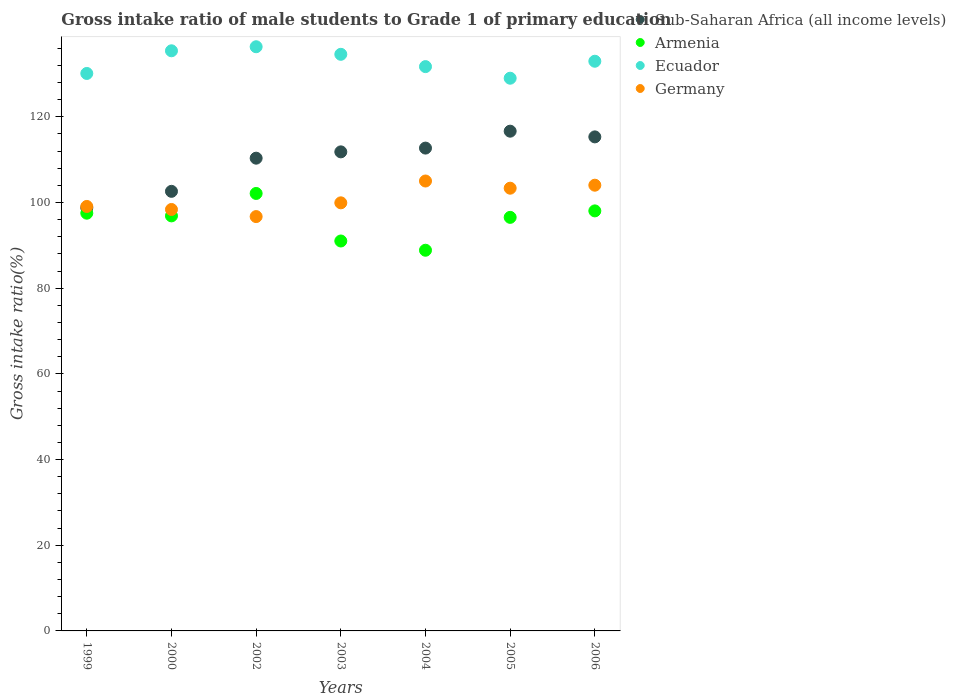What is the gross intake ratio in Armenia in 1999?
Ensure brevity in your answer.  97.51. Across all years, what is the maximum gross intake ratio in Germany?
Ensure brevity in your answer.  105.03. Across all years, what is the minimum gross intake ratio in Sub-Saharan Africa (all income levels)?
Provide a succinct answer. 98.76. In which year was the gross intake ratio in Sub-Saharan Africa (all income levels) maximum?
Ensure brevity in your answer.  2005. What is the total gross intake ratio in Germany in the graph?
Make the answer very short. 706.54. What is the difference between the gross intake ratio in Armenia in 2003 and that in 2005?
Give a very brief answer. -5.52. What is the difference between the gross intake ratio in Ecuador in 2006 and the gross intake ratio in Germany in 2002?
Provide a succinct answer. 36.26. What is the average gross intake ratio in Armenia per year?
Give a very brief answer. 95.86. In the year 2006, what is the difference between the gross intake ratio in Armenia and gross intake ratio in Sub-Saharan Africa (all income levels)?
Your answer should be very brief. -17.28. What is the ratio of the gross intake ratio in Germany in 2004 to that in 2006?
Your response must be concise. 1.01. Is the difference between the gross intake ratio in Armenia in 2000 and 2006 greater than the difference between the gross intake ratio in Sub-Saharan Africa (all income levels) in 2000 and 2006?
Your answer should be very brief. Yes. What is the difference between the highest and the second highest gross intake ratio in Armenia?
Offer a very short reply. 4.07. What is the difference between the highest and the lowest gross intake ratio in Ecuador?
Give a very brief answer. 7.34. Is it the case that in every year, the sum of the gross intake ratio in Sub-Saharan Africa (all income levels) and gross intake ratio in Ecuador  is greater than the sum of gross intake ratio in Germany and gross intake ratio in Armenia?
Give a very brief answer. Yes. Does the gross intake ratio in Germany monotonically increase over the years?
Make the answer very short. No. Is the gross intake ratio in Ecuador strictly less than the gross intake ratio in Sub-Saharan Africa (all income levels) over the years?
Your answer should be very brief. No. What is the difference between two consecutive major ticks on the Y-axis?
Ensure brevity in your answer.  20. Are the values on the major ticks of Y-axis written in scientific E-notation?
Your answer should be compact. No. Does the graph contain any zero values?
Make the answer very short. No. Does the graph contain grids?
Offer a very short reply. No. How are the legend labels stacked?
Give a very brief answer. Vertical. What is the title of the graph?
Ensure brevity in your answer.  Gross intake ratio of male students to Grade 1 of primary education. What is the label or title of the Y-axis?
Your answer should be very brief. Gross intake ratio(%). What is the Gross intake ratio(%) of Sub-Saharan Africa (all income levels) in 1999?
Your answer should be compact. 98.76. What is the Gross intake ratio(%) of Armenia in 1999?
Your answer should be very brief. 97.51. What is the Gross intake ratio(%) in Ecuador in 1999?
Make the answer very short. 130.13. What is the Gross intake ratio(%) of Germany in 1999?
Offer a very short reply. 99.09. What is the Gross intake ratio(%) of Sub-Saharan Africa (all income levels) in 2000?
Your answer should be very brief. 102.61. What is the Gross intake ratio(%) of Armenia in 2000?
Provide a short and direct response. 96.89. What is the Gross intake ratio(%) in Ecuador in 2000?
Keep it short and to the point. 135.42. What is the Gross intake ratio(%) in Germany in 2000?
Provide a short and direct response. 98.38. What is the Gross intake ratio(%) in Sub-Saharan Africa (all income levels) in 2002?
Ensure brevity in your answer.  110.36. What is the Gross intake ratio(%) in Armenia in 2002?
Keep it short and to the point. 102.12. What is the Gross intake ratio(%) in Ecuador in 2002?
Your answer should be compact. 136.37. What is the Gross intake ratio(%) in Germany in 2002?
Provide a short and direct response. 96.72. What is the Gross intake ratio(%) in Sub-Saharan Africa (all income levels) in 2003?
Offer a terse response. 111.83. What is the Gross intake ratio(%) of Armenia in 2003?
Provide a succinct answer. 91.02. What is the Gross intake ratio(%) of Ecuador in 2003?
Offer a very short reply. 134.6. What is the Gross intake ratio(%) of Germany in 2003?
Your response must be concise. 99.93. What is the Gross intake ratio(%) in Sub-Saharan Africa (all income levels) in 2004?
Keep it short and to the point. 112.71. What is the Gross intake ratio(%) of Armenia in 2004?
Offer a terse response. 88.86. What is the Gross intake ratio(%) in Ecuador in 2004?
Offer a terse response. 131.73. What is the Gross intake ratio(%) in Germany in 2004?
Your answer should be very brief. 105.03. What is the Gross intake ratio(%) of Sub-Saharan Africa (all income levels) in 2005?
Give a very brief answer. 116.66. What is the Gross intake ratio(%) of Armenia in 2005?
Give a very brief answer. 96.54. What is the Gross intake ratio(%) in Ecuador in 2005?
Make the answer very short. 129.02. What is the Gross intake ratio(%) of Germany in 2005?
Ensure brevity in your answer.  103.35. What is the Gross intake ratio(%) in Sub-Saharan Africa (all income levels) in 2006?
Give a very brief answer. 115.33. What is the Gross intake ratio(%) in Armenia in 2006?
Provide a succinct answer. 98.05. What is the Gross intake ratio(%) of Ecuador in 2006?
Give a very brief answer. 132.98. What is the Gross intake ratio(%) of Germany in 2006?
Offer a terse response. 104.05. Across all years, what is the maximum Gross intake ratio(%) in Sub-Saharan Africa (all income levels)?
Ensure brevity in your answer.  116.66. Across all years, what is the maximum Gross intake ratio(%) in Armenia?
Make the answer very short. 102.12. Across all years, what is the maximum Gross intake ratio(%) in Ecuador?
Offer a terse response. 136.37. Across all years, what is the maximum Gross intake ratio(%) of Germany?
Make the answer very short. 105.03. Across all years, what is the minimum Gross intake ratio(%) of Sub-Saharan Africa (all income levels)?
Keep it short and to the point. 98.76. Across all years, what is the minimum Gross intake ratio(%) of Armenia?
Offer a very short reply. 88.86. Across all years, what is the minimum Gross intake ratio(%) of Ecuador?
Give a very brief answer. 129.02. Across all years, what is the minimum Gross intake ratio(%) of Germany?
Your response must be concise. 96.72. What is the total Gross intake ratio(%) in Sub-Saharan Africa (all income levels) in the graph?
Your answer should be very brief. 768.26. What is the total Gross intake ratio(%) of Armenia in the graph?
Keep it short and to the point. 671. What is the total Gross intake ratio(%) of Ecuador in the graph?
Keep it short and to the point. 930.26. What is the total Gross intake ratio(%) of Germany in the graph?
Provide a succinct answer. 706.54. What is the difference between the Gross intake ratio(%) in Sub-Saharan Africa (all income levels) in 1999 and that in 2000?
Your answer should be compact. -3.85. What is the difference between the Gross intake ratio(%) in Armenia in 1999 and that in 2000?
Your response must be concise. 0.63. What is the difference between the Gross intake ratio(%) in Ecuador in 1999 and that in 2000?
Ensure brevity in your answer.  -5.29. What is the difference between the Gross intake ratio(%) in Germany in 1999 and that in 2000?
Offer a terse response. 0.71. What is the difference between the Gross intake ratio(%) of Sub-Saharan Africa (all income levels) in 1999 and that in 2002?
Give a very brief answer. -11.59. What is the difference between the Gross intake ratio(%) of Armenia in 1999 and that in 2002?
Give a very brief answer. -4.61. What is the difference between the Gross intake ratio(%) in Ecuador in 1999 and that in 2002?
Your response must be concise. -6.23. What is the difference between the Gross intake ratio(%) of Germany in 1999 and that in 2002?
Keep it short and to the point. 2.37. What is the difference between the Gross intake ratio(%) in Sub-Saharan Africa (all income levels) in 1999 and that in 2003?
Keep it short and to the point. -13.07. What is the difference between the Gross intake ratio(%) in Armenia in 1999 and that in 2003?
Your answer should be compact. 6.49. What is the difference between the Gross intake ratio(%) of Ecuador in 1999 and that in 2003?
Give a very brief answer. -4.47. What is the difference between the Gross intake ratio(%) in Germany in 1999 and that in 2003?
Provide a succinct answer. -0.84. What is the difference between the Gross intake ratio(%) of Sub-Saharan Africa (all income levels) in 1999 and that in 2004?
Keep it short and to the point. -13.95. What is the difference between the Gross intake ratio(%) in Armenia in 1999 and that in 2004?
Offer a very short reply. 8.65. What is the difference between the Gross intake ratio(%) in Ecuador in 1999 and that in 2004?
Provide a succinct answer. -1.6. What is the difference between the Gross intake ratio(%) in Germany in 1999 and that in 2004?
Provide a succinct answer. -5.94. What is the difference between the Gross intake ratio(%) of Sub-Saharan Africa (all income levels) in 1999 and that in 2005?
Your answer should be compact. -17.89. What is the difference between the Gross intake ratio(%) of Armenia in 1999 and that in 2005?
Make the answer very short. 0.97. What is the difference between the Gross intake ratio(%) in Ecuador in 1999 and that in 2005?
Make the answer very short. 1.11. What is the difference between the Gross intake ratio(%) in Germany in 1999 and that in 2005?
Provide a short and direct response. -4.26. What is the difference between the Gross intake ratio(%) in Sub-Saharan Africa (all income levels) in 1999 and that in 2006?
Your answer should be very brief. -16.56. What is the difference between the Gross intake ratio(%) of Armenia in 1999 and that in 2006?
Ensure brevity in your answer.  -0.54. What is the difference between the Gross intake ratio(%) of Ecuador in 1999 and that in 2006?
Make the answer very short. -2.85. What is the difference between the Gross intake ratio(%) in Germany in 1999 and that in 2006?
Make the answer very short. -4.96. What is the difference between the Gross intake ratio(%) in Sub-Saharan Africa (all income levels) in 2000 and that in 2002?
Your answer should be compact. -7.74. What is the difference between the Gross intake ratio(%) in Armenia in 2000 and that in 2002?
Make the answer very short. -5.24. What is the difference between the Gross intake ratio(%) in Ecuador in 2000 and that in 2002?
Your answer should be compact. -0.94. What is the difference between the Gross intake ratio(%) of Germany in 2000 and that in 2002?
Keep it short and to the point. 1.66. What is the difference between the Gross intake ratio(%) of Sub-Saharan Africa (all income levels) in 2000 and that in 2003?
Offer a very short reply. -9.22. What is the difference between the Gross intake ratio(%) of Armenia in 2000 and that in 2003?
Provide a short and direct response. 5.86. What is the difference between the Gross intake ratio(%) in Ecuador in 2000 and that in 2003?
Provide a succinct answer. 0.82. What is the difference between the Gross intake ratio(%) in Germany in 2000 and that in 2003?
Your answer should be very brief. -1.55. What is the difference between the Gross intake ratio(%) of Sub-Saharan Africa (all income levels) in 2000 and that in 2004?
Your answer should be very brief. -10.1. What is the difference between the Gross intake ratio(%) in Armenia in 2000 and that in 2004?
Make the answer very short. 8.02. What is the difference between the Gross intake ratio(%) of Ecuador in 2000 and that in 2004?
Provide a succinct answer. 3.69. What is the difference between the Gross intake ratio(%) in Germany in 2000 and that in 2004?
Make the answer very short. -6.65. What is the difference between the Gross intake ratio(%) of Sub-Saharan Africa (all income levels) in 2000 and that in 2005?
Give a very brief answer. -14.04. What is the difference between the Gross intake ratio(%) of Armenia in 2000 and that in 2005?
Ensure brevity in your answer.  0.35. What is the difference between the Gross intake ratio(%) of Ecuador in 2000 and that in 2005?
Your answer should be very brief. 6.4. What is the difference between the Gross intake ratio(%) in Germany in 2000 and that in 2005?
Give a very brief answer. -4.97. What is the difference between the Gross intake ratio(%) of Sub-Saharan Africa (all income levels) in 2000 and that in 2006?
Make the answer very short. -12.71. What is the difference between the Gross intake ratio(%) in Armenia in 2000 and that in 2006?
Ensure brevity in your answer.  -1.17. What is the difference between the Gross intake ratio(%) of Ecuador in 2000 and that in 2006?
Keep it short and to the point. 2.44. What is the difference between the Gross intake ratio(%) of Germany in 2000 and that in 2006?
Offer a terse response. -5.67. What is the difference between the Gross intake ratio(%) in Sub-Saharan Africa (all income levels) in 2002 and that in 2003?
Your answer should be very brief. -1.47. What is the difference between the Gross intake ratio(%) of Armenia in 2002 and that in 2003?
Provide a short and direct response. 11.1. What is the difference between the Gross intake ratio(%) in Ecuador in 2002 and that in 2003?
Give a very brief answer. 1.77. What is the difference between the Gross intake ratio(%) of Germany in 2002 and that in 2003?
Ensure brevity in your answer.  -3.21. What is the difference between the Gross intake ratio(%) of Sub-Saharan Africa (all income levels) in 2002 and that in 2004?
Your response must be concise. -2.35. What is the difference between the Gross intake ratio(%) in Armenia in 2002 and that in 2004?
Your response must be concise. 13.26. What is the difference between the Gross intake ratio(%) in Ecuador in 2002 and that in 2004?
Give a very brief answer. 4.64. What is the difference between the Gross intake ratio(%) in Germany in 2002 and that in 2004?
Your answer should be very brief. -8.3. What is the difference between the Gross intake ratio(%) of Armenia in 2002 and that in 2005?
Provide a succinct answer. 5.58. What is the difference between the Gross intake ratio(%) of Ecuador in 2002 and that in 2005?
Provide a short and direct response. 7.34. What is the difference between the Gross intake ratio(%) of Germany in 2002 and that in 2005?
Provide a succinct answer. -6.63. What is the difference between the Gross intake ratio(%) in Sub-Saharan Africa (all income levels) in 2002 and that in 2006?
Provide a succinct answer. -4.97. What is the difference between the Gross intake ratio(%) in Armenia in 2002 and that in 2006?
Keep it short and to the point. 4.07. What is the difference between the Gross intake ratio(%) of Ecuador in 2002 and that in 2006?
Your answer should be very brief. 3.38. What is the difference between the Gross intake ratio(%) of Germany in 2002 and that in 2006?
Keep it short and to the point. -7.32. What is the difference between the Gross intake ratio(%) of Sub-Saharan Africa (all income levels) in 2003 and that in 2004?
Ensure brevity in your answer.  -0.88. What is the difference between the Gross intake ratio(%) in Armenia in 2003 and that in 2004?
Make the answer very short. 2.16. What is the difference between the Gross intake ratio(%) of Ecuador in 2003 and that in 2004?
Your response must be concise. 2.87. What is the difference between the Gross intake ratio(%) in Germany in 2003 and that in 2004?
Offer a terse response. -5.09. What is the difference between the Gross intake ratio(%) in Sub-Saharan Africa (all income levels) in 2003 and that in 2005?
Provide a succinct answer. -4.83. What is the difference between the Gross intake ratio(%) of Armenia in 2003 and that in 2005?
Provide a short and direct response. -5.52. What is the difference between the Gross intake ratio(%) of Ecuador in 2003 and that in 2005?
Your answer should be compact. 5.58. What is the difference between the Gross intake ratio(%) in Germany in 2003 and that in 2005?
Offer a very short reply. -3.42. What is the difference between the Gross intake ratio(%) of Sub-Saharan Africa (all income levels) in 2003 and that in 2006?
Make the answer very short. -3.5. What is the difference between the Gross intake ratio(%) in Armenia in 2003 and that in 2006?
Your answer should be compact. -7.03. What is the difference between the Gross intake ratio(%) in Ecuador in 2003 and that in 2006?
Make the answer very short. 1.62. What is the difference between the Gross intake ratio(%) of Germany in 2003 and that in 2006?
Keep it short and to the point. -4.12. What is the difference between the Gross intake ratio(%) in Sub-Saharan Africa (all income levels) in 2004 and that in 2005?
Your answer should be very brief. -3.95. What is the difference between the Gross intake ratio(%) of Armenia in 2004 and that in 2005?
Give a very brief answer. -7.67. What is the difference between the Gross intake ratio(%) of Ecuador in 2004 and that in 2005?
Make the answer very short. 2.71. What is the difference between the Gross intake ratio(%) in Germany in 2004 and that in 2005?
Provide a short and direct response. 1.68. What is the difference between the Gross intake ratio(%) in Sub-Saharan Africa (all income levels) in 2004 and that in 2006?
Keep it short and to the point. -2.62. What is the difference between the Gross intake ratio(%) in Armenia in 2004 and that in 2006?
Ensure brevity in your answer.  -9.19. What is the difference between the Gross intake ratio(%) of Ecuador in 2004 and that in 2006?
Your answer should be very brief. -1.26. What is the difference between the Gross intake ratio(%) of Germany in 2004 and that in 2006?
Make the answer very short. 0.98. What is the difference between the Gross intake ratio(%) of Sub-Saharan Africa (all income levels) in 2005 and that in 2006?
Your answer should be very brief. 1.33. What is the difference between the Gross intake ratio(%) in Armenia in 2005 and that in 2006?
Give a very brief answer. -1.51. What is the difference between the Gross intake ratio(%) of Ecuador in 2005 and that in 2006?
Your answer should be compact. -3.96. What is the difference between the Gross intake ratio(%) in Germany in 2005 and that in 2006?
Ensure brevity in your answer.  -0.7. What is the difference between the Gross intake ratio(%) of Sub-Saharan Africa (all income levels) in 1999 and the Gross intake ratio(%) of Armenia in 2000?
Offer a terse response. 1.88. What is the difference between the Gross intake ratio(%) of Sub-Saharan Africa (all income levels) in 1999 and the Gross intake ratio(%) of Ecuador in 2000?
Your answer should be compact. -36.66. What is the difference between the Gross intake ratio(%) of Sub-Saharan Africa (all income levels) in 1999 and the Gross intake ratio(%) of Germany in 2000?
Make the answer very short. 0.38. What is the difference between the Gross intake ratio(%) of Armenia in 1999 and the Gross intake ratio(%) of Ecuador in 2000?
Ensure brevity in your answer.  -37.91. What is the difference between the Gross intake ratio(%) of Armenia in 1999 and the Gross intake ratio(%) of Germany in 2000?
Your response must be concise. -0.87. What is the difference between the Gross intake ratio(%) of Ecuador in 1999 and the Gross intake ratio(%) of Germany in 2000?
Ensure brevity in your answer.  31.75. What is the difference between the Gross intake ratio(%) in Sub-Saharan Africa (all income levels) in 1999 and the Gross intake ratio(%) in Armenia in 2002?
Your answer should be very brief. -3.36. What is the difference between the Gross intake ratio(%) of Sub-Saharan Africa (all income levels) in 1999 and the Gross intake ratio(%) of Ecuador in 2002?
Provide a short and direct response. -37.6. What is the difference between the Gross intake ratio(%) in Sub-Saharan Africa (all income levels) in 1999 and the Gross intake ratio(%) in Germany in 2002?
Keep it short and to the point. 2.04. What is the difference between the Gross intake ratio(%) of Armenia in 1999 and the Gross intake ratio(%) of Ecuador in 2002?
Offer a very short reply. -38.85. What is the difference between the Gross intake ratio(%) in Armenia in 1999 and the Gross intake ratio(%) in Germany in 2002?
Provide a short and direct response. 0.79. What is the difference between the Gross intake ratio(%) of Ecuador in 1999 and the Gross intake ratio(%) of Germany in 2002?
Give a very brief answer. 33.41. What is the difference between the Gross intake ratio(%) in Sub-Saharan Africa (all income levels) in 1999 and the Gross intake ratio(%) in Armenia in 2003?
Your response must be concise. 7.74. What is the difference between the Gross intake ratio(%) in Sub-Saharan Africa (all income levels) in 1999 and the Gross intake ratio(%) in Ecuador in 2003?
Ensure brevity in your answer.  -35.84. What is the difference between the Gross intake ratio(%) of Sub-Saharan Africa (all income levels) in 1999 and the Gross intake ratio(%) of Germany in 2003?
Ensure brevity in your answer.  -1.17. What is the difference between the Gross intake ratio(%) of Armenia in 1999 and the Gross intake ratio(%) of Ecuador in 2003?
Provide a succinct answer. -37.09. What is the difference between the Gross intake ratio(%) in Armenia in 1999 and the Gross intake ratio(%) in Germany in 2003?
Give a very brief answer. -2.42. What is the difference between the Gross intake ratio(%) in Ecuador in 1999 and the Gross intake ratio(%) in Germany in 2003?
Your response must be concise. 30.2. What is the difference between the Gross intake ratio(%) of Sub-Saharan Africa (all income levels) in 1999 and the Gross intake ratio(%) of Armenia in 2004?
Offer a terse response. 9.9. What is the difference between the Gross intake ratio(%) in Sub-Saharan Africa (all income levels) in 1999 and the Gross intake ratio(%) in Ecuador in 2004?
Ensure brevity in your answer.  -32.97. What is the difference between the Gross intake ratio(%) of Sub-Saharan Africa (all income levels) in 1999 and the Gross intake ratio(%) of Germany in 2004?
Offer a very short reply. -6.26. What is the difference between the Gross intake ratio(%) in Armenia in 1999 and the Gross intake ratio(%) in Ecuador in 2004?
Offer a terse response. -34.22. What is the difference between the Gross intake ratio(%) of Armenia in 1999 and the Gross intake ratio(%) of Germany in 2004?
Make the answer very short. -7.51. What is the difference between the Gross intake ratio(%) in Ecuador in 1999 and the Gross intake ratio(%) in Germany in 2004?
Your answer should be compact. 25.11. What is the difference between the Gross intake ratio(%) of Sub-Saharan Africa (all income levels) in 1999 and the Gross intake ratio(%) of Armenia in 2005?
Keep it short and to the point. 2.22. What is the difference between the Gross intake ratio(%) of Sub-Saharan Africa (all income levels) in 1999 and the Gross intake ratio(%) of Ecuador in 2005?
Give a very brief answer. -30.26. What is the difference between the Gross intake ratio(%) in Sub-Saharan Africa (all income levels) in 1999 and the Gross intake ratio(%) in Germany in 2005?
Give a very brief answer. -4.58. What is the difference between the Gross intake ratio(%) of Armenia in 1999 and the Gross intake ratio(%) of Ecuador in 2005?
Keep it short and to the point. -31.51. What is the difference between the Gross intake ratio(%) of Armenia in 1999 and the Gross intake ratio(%) of Germany in 2005?
Ensure brevity in your answer.  -5.83. What is the difference between the Gross intake ratio(%) in Ecuador in 1999 and the Gross intake ratio(%) in Germany in 2005?
Offer a very short reply. 26.78. What is the difference between the Gross intake ratio(%) of Sub-Saharan Africa (all income levels) in 1999 and the Gross intake ratio(%) of Armenia in 2006?
Ensure brevity in your answer.  0.71. What is the difference between the Gross intake ratio(%) in Sub-Saharan Africa (all income levels) in 1999 and the Gross intake ratio(%) in Ecuador in 2006?
Give a very brief answer. -34.22. What is the difference between the Gross intake ratio(%) in Sub-Saharan Africa (all income levels) in 1999 and the Gross intake ratio(%) in Germany in 2006?
Offer a terse response. -5.28. What is the difference between the Gross intake ratio(%) of Armenia in 1999 and the Gross intake ratio(%) of Ecuador in 2006?
Provide a succinct answer. -35.47. What is the difference between the Gross intake ratio(%) in Armenia in 1999 and the Gross intake ratio(%) in Germany in 2006?
Offer a terse response. -6.53. What is the difference between the Gross intake ratio(%) in Ecuador in 1999 and the Gross intake ratio(%) in Germany in 2006?
Your response must be concise. 26.09. What is the difference between the Gross intake ratio(%) of Sub-Saharan Africa (all income levels) in 2000 and the Gross intake ratio(%) of Armenia in 2002?
Provide a short and direct response. 0.49. What is the difference between the Gross intake ratio(%) of Sub-Saharan Africa (all income levels) in 2000 and the Gross intake ratio(%) of Ecuador in 2002?
Offer a very short reply. -33.75. What is the difference between the Gross intake ratio(%) of Sub-Saharan Africa (all income levels) in 2000 and the Gross intake ratio(%) of Germany in 2002?
Ensure brevity in your answer.  5.89. What is the difference between the Gross intake ratio(%) of Armenia in 2000 and the Gross intake ratio(%) of Ecuador in 2002?
Provide a short and direct response. -39.48. What is the difference between the Gross intake ratio(%) in Armenia in 2000 and the Gross intake ratio(%) in Germany in 2002?
Your answer should be very brief. 0.16. What is the difference between the Gross intake ratio(%) in Ecuador in 2000 and the Gross intake ratio(%) in Germany in 2002?
Provide a short and direct response. 38.7. What is the difference between the Gross intake ratio(%) in Sub-Saharan Africa (all income levels) in 2000 and the Gross intake ratio(%) in Armenia in 2003?
Your answer should be compact. 11.59. What is the difference between the Gross intake ratio(%) in Sub-Saharan Africa (all income levels) in 2000 and the Gross intake ratio(%) in Ecuador in 2003?
Make the answer very short. -31.99. What is the difference between the Gross intake ratio(%) in Sub-Saharan Africa (all income levels) in 2000 and the Gross intake ratio(%) in Germany in 2003?
Provide a succinct answer. 2.68. What is the difference between the Gross intake ratio(%) in Armenia in 2000 and the Gross intake ratio(%) in Ecuador in 2003?
Your response must be concise. -37.72. What is the difference between the Gross intake ratio(%) of Armenia in 2000 and the Gross intake ratio(%) of Germany in 2003?
Provide a short and direct response. -3.05. What is the difference between the Gross intake ratio(%) in Ecuador in 2000 and the Gross intake ratio(%) in Germany in 2003?
Your answer should be compact. 35.49. What is the difference between the Gross intake ratio(%) of Sub-Saharan Africa (all income levels) in 2000 and the Gross intake ratio(%) of Armenia in 2004?
Provide a succinct answer. 13.75. What is the difference between the Gross intake ratio(%) of Sub-Saharan Africa (all income levels) in 2000 and the Gross intake ratio(%) of Ecuador in 2004?
Your response must be concise. -29.12. What is the difference between the Gross intake ratio(%) of Sub-Saharan Africa (all income levels) in 2000 and the Gross intake ratio(%) of Germany in 2004?
Provide a succinct answer. -2.41. What is the difference between the Gross intake ratio(%) of Armenia in 2000 and the Gross intake ratio(%) of Ecuador in 2004?
Offer a very short reply. -34.84. What is the difference between the Gross intake ratio(%) of Armenia in 2000 and the Gross intake ratio(%) of Germany in 2004?
Ensure brevity in your answer.  -8.14. What is the difference between the Gross intake ratio(%) in Ecuador in 2000 and the Gross intake ratio(%) in Germany in 2004?
Offer a terse response. 30.4. What is the difference between the Gross intake ratio(%) of Sub-Saharan Africa (all income levels) in 2000 and the Gross intake ratio(%) of Armenia in 2005?
Provide a short and direct response. 6.07. What is the difference between the Gross intake ratio(%) in Sub-Saharan Africa (all income levels) in 2000 and the Gross intake ratio(%) in Ecuador in 2005?
Make the answer very short. -26.41. What is the difference between the Gross intake ratio(%) of Sub-Saharan Africa (all income levels) in 2000 and the Gross intake ratio(%) of Germany in 2005?
Keep it short and to the point. -0.73. What is the difference between the Gross intake ratio(%) in Armenia in 2000 and the Gross intake ratio(%) in Ecuador in 2005?
Give a very brief answer. -32.14. What is the difference between the Gross intake ratio(%) of Armenia in 2000 and the Gross intake ratio(%) of Germany in 2005?
Your answer should be compact. -6.46. What is the difference between the Gross intake ratio(%) in Ecuador in 2000 and the Gross intake ratio(%) in Germany in 2005?
Your response must be concise. 32.07. What is the difference between the Gross intake ratio(%) in Sub-Saharan Africa (all income levels) in 2000 and the Gross intake ratio(%) in Armenia in 2006?
Keep it short and to the point. 4.56. What is the difference between the Gross intake ratio(%) of Sub-Saharan Africa (all income levels) in 2000 and the Gross intake ratio(%) of Ecuador in 2006?
Ensure brevity in your answer.  -30.37. What is the difference between the Gross intake ratio(%) in Sub-Saharan Africa (all income levels) in 2000 and the Gross intake ratio(%) in Germany in 2006?
Offer a terse response. -1.43. What is the difference between the Gross intake ratio(%) of Armenia in 2000 and the Gross intake ratio(%) of Ecuador in 2006?
Your response must be concise. -36.1. What is the difference between the Gross intake ratio(%) in Armenia in 2000 and the Gross intake ratio(%) in Germany in 2006?
Your response must be concise. -7.16. What is the difference between the Gross intake ratio(%) in Ecuador in 2000 and the Gross intake ratio(%) in Germany in 2006?
Provide a succinct answer. 31.38. What is the difference between the Gross intake ratio(%) of Sub-Saharan Africa (all income levels) in 2002 and the Gross intake ratio(%) of Armenia in 2003?
Keep it short and to the point. 19.33. What is the difference between the Gross intake ratio(%) of Sub-Saharan Africa (all income levels) in 2002 and the Gross intake ratio(%) of Ecuador in 2003?
Give a very brief answer. -24.24. What is the difference between the Gross intake ratio(%) in Sub-Saharan Africa (all income levels) in 2002 and the Gross intake ratio(%) in Germany in 2003?
Provide a succinct answer. 10.42. What is the difference between the Gross intake ratio(%) in Armenia in 2002 and the Gross intake ratio(%) in Ecuador in 2003?
Offer a very short reply. -32.48. What is the difference between the Gross intake ratio(%) of Armenia in 2002 and the Gross intake ratio(%) of Germany in 2003?
Make the answer very short. 2.19. What is the difference between the Gross intake ratio(%) of Ecuador in 2002 and the Gross intake ratio(%) of Germany in 2003?
Your answer should be very brief. 36.44. What is the difference between the Gross intake ratio(%) in Sub-Saharan Africa (all income levels) in 2002 and the Gross intake ratio(%) in Armenia in 2004?
Offer a very short reply. 21.49. What is the difference between the Gross intake ratio(%) of Sub-Saharan Africa (all income levels) in 2002 and the Gross intake ratio(%) of Ecuador in 2004?
Make the answer very short. -21.37. What is the difference between the Gross intake ratio(%) in Sub-Saharan Africa (all income levels) in 2002 and the Gross intake ratio(%) in Germany in 2004?
Your response must be concise. 5.33. What is the difference between the Gross intake ratio(%) of Armenia in 2002 and the Gross intake ratio(%) of Ecuador in 2004?
Provide a succinct answer. -29.61. What is the difference between the Gross intake ratio(%) in Armenia in 2002 and the Gross intake ratio(%) in Germany in 2004?
Provide a short and direct response. -2.9. What is the difference between the Gross intake ratio(%) of Ecuador in 2002 and the Gross intake ratio(%) of Germany in 2004?
Your response must be concise. 31.34. What is the difference between the Gross intake ratio(%) of Sub-Saharan Africa (all income levels) in 2002 and the Gross intake ratio(%) of Armenia in 2005?
Give a very brief answer. 13.82. What is the difference between the Gross intake ratio(%) of Sub-Saharan Africa (all income levels) in 2002 and the Gross intake ratio(%) of Ecuador in 2005?
Your answer should be compact. -18.67. What is the difference between the Gross intake ratio(%) of Sub-Saharan Africa (all income levels) in 2002 and the Gross intake ratio(%) of Germany in 2005?
Offer a very short reply. 7.01. What is the difference between the Gross intake ratio(%) in Armenia in 2002 and the Gross intake ratio(%) in Ecuador in 2005?
Offer a very short reply. -26.9. What is the difference between the Gross intake ratio(%) of Armenia in 2002 and the Gross intake ratio(%) of Germany in 2005?
Provide a short and direct response. -1.23. What is the difference between the Gross intake ratio(%) of Ecuador in 2002 and the Gross intake ratio(%) of Germany in 2005?
Your answer should be compact. 33.02. What is the difference between the Gross intake ratio(%) in Sub-Saharan Africa (all income levels) in 2002 and the Gross intake ratio(%) in Armenia in 2006?
Offer a terse response. 12.31. What is the difference between the Gross intake ratio(%) of Sub-Saharan Africa (all income levels) in 2002 and the Gross intake ratio(%) of Ecuador in 2006?
Offer a very short reply. -22.63. What is the difference between the Gross intake ratio(%) of Sub-Saharan Africa (all income levels) in 2002 and the Gross intake ratio(%) of Germany in 2006?
Your answer should be compact. 6.31. What is the difference between the Gross intake ratio(%) of Armenia in 2002 and the Gross intake ratio(%) of Ecuador in 2006?
Keep it short and to the point. -30.86. What is the difference between the Gross intake ratio(%) of Armenia in 2002 and the Gross intake ratio(%) of Germany in 2006?
Offer a very short reply. -1.93. What is the difference between the Gross intake ratio(%) in Ecuador in 2002 and the Gross intake ratio(%) in Germany in 2006?
Your answer should be very brief. 32.32. What is the difference between the Gross intake ratio(%) of Sub-Saharan Africa (all income levels) in 2003 and the Gross intake ratio(%) of Armenia in 2004?
Make the answer very short. 22.96. What is the difference between the Gross intake ratio(%) of Sub-Saharan Africa (all income levels) in 2003 and the Gross intake ratio(%) of Ecuador in 2004?
Offer a very short reply. -19.9. What is the difference between the Gross intake ratio(%) in Sub-Saharan Africa (all income levels) in 2003 and the Gross intake ratio(%) in Germany in 2004?
Give a very brief answer. 6.8. What is the difference between the Gross intake ratio(%) in Armenia in 2003 and the Gross intake ratio(%) in Ecuador in 2004?
Provide a succinct answer. -40.71. What is the difference between the Gross intake ratio(%) of Armenia in 2003 and the Gross intake ratio(%) of Germany in 2004?
Your answer should be compact. -14. What is the difference between the Gross intake ratio(%) of Ecuador in 2003 and the Gross intake ratio(%) of Germany in 2004?
Keep it short and to the point. 29.58. What is the difference between the Gross intake ratio(%) of Sub-Saharan Africa (all income levels) in 2003 and the Gross intake ratio(%) of Armenia in 2005?
Ensure brevity in your answer.  15.29. What is the difference between the Gross intake ratio(%) in Sub-Saharan Africa (all income levels) in 2003 and the Gross intake ratio(%) in Ecuador in 2005?
Keep it short and to the point. -17.19. What is the difference between the Gross intake ratio(%) in Sub-Saharan Africa (all income levels) in 2003 and the Gross intake ratio(%) in Germany in 2005?
Give a very brief answer. 8.48. What is the difference between the Gross intake ratio(%) in Armenia in 2003 and the Gross intake ratio(%) in Ecuador in 2005?
Keep it short and to the point. -38. What is the difference between the Gross intake ratio(%) in Armenia in 2003 and the Gross intake ratio(%) in Germany in 2005?
Offer a very short reply. -12.33. What is the difference between the Gross intake ratio(%) in Ecuador in 2003 and the Gross intake ratio(%) in Germany in 2005?
Give a very brief answer. 31.25. What is the difference between the Gross intake ratio(%) of Sub-Saharan Africa (all income levels) in 2003 and the Gross intake ratio(%) of Armenia in 2006?
Your answer should be very brief. 13.78. What is the difference between the Gross intake ratio(%) of Sub-Saharan Africa (all income levels) in 2003 and the Gross intake ratio(%) of Ecuador in 2006?
Your answer should be compact. -21.15. What is the difference between the Gross intake ratio(%) in Sub-Saharan Africa (all income levels) in 2003 and the Gross intake ratio(%) in Germany in 2006?
Your response must be concise. 7.78. What is the difference between the Gross intake ratio(%) of Armenia in 2003 and the Gross intake ratio(%) of Ecuador in 2006?
Offer a terse response. -41.96. What is the difference between the Gross intake ratio(%) in Armenia in 2003 and the Gross intake ratio(%) in Germany in 2006?
Your response must be concise. -13.03. What is the difference between the Gross intake ratio(%) in Ecuador in 2003 and the Gross intake ratio(%) in Germany in 2006?
Make the answer very short. 30.55. What is the difference between the Gross intake ratio(%) in Sub-Saharan Africa (all income levels) in 2004 and the Gross intake ratio(%) in Armenia in 2005?
Offer a terse response. 16.17. What is the difference between the Gross intake ratio(%) in Sub-Saharan Africa (all income levels) in 2004 and the Gross intake ratio(%) in Ecuador in 2005?
Keep it short and to the point. -16.31. What is the difference between the Gross intake ratio(%) in Sub-Saharan Africa (all income levels) in 2004 and the Gross intake ratio(%) in Germany in 2005?
Keep it short and to the point. 9.36. What is the difference between the Gross intake ratio(%) of Armenia in 2004 and the Gross intake ratio(%) of Ecuador in 2005?
Your answer should be very brief. -40.16. What is the difference between the Gross intake ratio(%) in Armenia in 2004 and the Gross intake ratio(%) in Germany in 2005?
Make the answer very short. -14.48. What is the difference between the Gross intake ratio(%) of Ecuador in 2004 and the Gross intake ratio(%) of Germany in 2005?
Your response must be concise. 28.38. What is the difference between the Gross intake ratio(%) in Sub-Saharan Africa (all income levels) in 2004 and the Gross intake ratio(%) in Armenia in 2006?
Give a very brief answer. 14.66. What is the difference between the Gross intake ratio(%) in Sub-Saharan Africa (all income levels) in 2004 and the Gross intake ratio(%) in Ecuador in 2006?
Your response must be concise. -20.28. What is the difference between the Gross intake ratio(%) in Sub-Saharan Africa (all income levels) in 2004 and the Gross intake ratio(%) in Germany in 2006?
Offer a terse response. 8.66. What is the difference between the Gross intake ratio(%) of Armenia in 2004 and the Gross intake ratio(%) of Ecuador in 2006?
Your answer should be compact. -44.12. What is the difference between the Gross intake ratio(%) of Armenia in 2004 and the Gross intake ratio(%) of Germany in 2006?
Provide a short and direct response. -15.18. What is the difference between the Gross intake ratio(%) in Ecuador in 2004 and the Gross intake ratio(%) in Germany in 2006?
Offer a terse response. 27.68. What is the difference between the Gross intake ratio(%) of Sub-Saharan Africa (all income levels) in 2005 and the Gross intake ratio(%) of Armenia in 2006?
Your response must be concise. 18.61. What is the difference between the Gross intake ratio(%) of Sub-Saharan Africa (all income levels) in 2005 and the Gross intake ratio(%) of Ecuador in 2006?
Your answer should be compact. -16.33. What is the difference between the Gross intake ratio(%) in Sub-Saharan Africa (all income levels) in 2005 and the Gross intake ratio(%) in Germany in 2006?
Give a very brief answer. 12.61. What is the difference between the Gross intake ratio(%) of Armenia in 2005 and the Gross intake ratio(%) of Ecuador in 2006?
Your response must be concise. -36.44. What is the difference between the Gross intake ratio(%) of Armenia in 2005 and the Gross intake ratio(%) of Germany in 2006?
Your answer should be compact. -7.51. What is the difference between the Gross intake ratio(%) of Ecuador in 2005 and the Gross intake ratio(%) of Germany in 2006?
Offer a very short reply. 24.97. What is the average Gross intake ratio(%) in Sub-Saharan Africa (all income levels) per year?
Your answer should be compact. 109.75. What is the average Gross intake ratio(%) in Armenia per year?
Offer a very short reply. 95.86. What is the average Gross intake ratio(%) in Ecuador per year?
Provide a short and direct response. 132.89. What is the average Gross intake ratio(%) of Germany per year?
Your response must be concise. 100.93. In the year 1999, what is the difference between the Gross intake ratio(%) in Sub-Saharan Africa (all income levels) and Gross intake ratio(%) in Armenia?
Give a very brief answer. 1.25. In the year 1999, what is the difference between the Gross intake ratio(%) of Sub-Saharan Africa (all income levels) and Gross intake ratio(%) of Ecuador?
Your answer should be very brief. -31.37. In the year 1999, what is the difference between the Gross intake ratio(%) of Sub-Saharan Africa (all income levels) and Gross intake ratio(%) of Germany?
Provide a succinct answer. -0.32. In the year 1999, what is the difference between the Gross intake ratio(%) in Armenia and Gross intake ratio(%) in Ecuador?
Offer a very short reply. -32.62. In the year 1999, what is the difference between the Gross intake ratio(%) in Armenia and Gross intake ratio(%) in Germany?
Provide a succinct answer. -1.57. In the year 1999, what is the difference between the Gross intake ratio(%) of Ecuador and Gross intake ratio(%) of Germany?
Give a very brief answer. 31.04. In the year 2000, what is the difference between the Gross intake ratio(%) of Sub-Saharan Africa (all income levels) and Gross intake ratio(%) of Armenia?
Provide a succinct answer. 5.73. In the year 2000, what is the difference between the Gross intake ratio(%) in Sub-Saharan Africa (all income levels) and Gross intake ratio(%) in Ecuador?
Provide a short and direct response. -32.81. In the year 2000, what is the difference between the Gross intake ratio(%) in Sub-Saharan Africa (all income levels) and Gross intake ratio(%) in Germany?
Provide a succinct answer. 4.23. In the year 2000, what is the difference between the Gross intake ratio(%) of Armenia and Gross intake ratio(%) of Ecuador?
Ensure brevity in your answer.  -38.54. In the year 2000, what is the difference between the Gross intake ratio(%) in Armenia and Gross intake ratio(%) in Germany?
Offer a very short reply. -1.49. In the year 2000, what is the difference between the Gross intake ratio(%) in Ecuador and Gross intake ratio(%) in Germany?
Ensure brevity in your answer.  37.04. In the year 2002, what is the difference between the Gross intake ratio(%) in Sub-Saharan Africa (all income levels) and Gross intake ratio(%) in Armenia?
Ensure brevity in your answer.  8.24. In the year 2002, what is the difference between the Gross intake ratio(%) in Sub-Saharan Africa (all income levels) and Gross intake ratio(%) in Ecuador?
Your answer should be very brief. -26.01. In the year 2002, what is the difference between the Gross intake ratio(%) of Sub-Saharan Africa (all income levels) and Gross intake ratio(%) of Germany?
Make the answer very short. 13.63. In the year 2002, what is the difference between the Gross intake ratio(%) in Armenia and Gross intake ratio(%) in Ecuador?
Your answer should be compact. -34.25. In the year 2002, what is the difference between the Gross intake ratio(%) in Armenia and Gross intake ratio(%) in Germany?
Make the answer very short. 5.4. In the year 2002, what is the difference between the Gross intake ratio(%) of Ecuador and Gross intake ratio(%) of Germany?
Offer a terse response. 39.64. In the year 2003, what is the difference between the Gross intake ratio(%) in Sub-Saharan Africa (all income levels) and Gross intake ratio(%) in Armenia?
Offer a very short reply. 20.81. In the year 2003, what is the difference between the Gross intake ratio(%) in Sub-Saharan Africa (all income levels) and Gross intake ratio(%) in Ecuador?
Your answer should be compact. -22.77. In the year 2003, what is the difference between the Gross intake ratio(%) of Sub-Saharan Africa (all income levels) and Gross intake ratio(%) of Germany?
Your answer should be very brief. 11.9. In the year 2003, what is the difference between the Gross intake ratio(%) of Armenia and Gross intake ratio(%) of Ecuador?
Give a very brief answer. -43.58. In the year 2003, what is the difference between the Gross intake ratio(%) of Armenia and Gross intake ratio(%) of Germany?
Provide a succinct answer. -8.91. In the year 2003, what is the difference between the Gross intake ratio(%) in Ecuador and Gross intake ratio(%) in Germany?
Your answer should be very brief. 34.67. In the year 2004, what is the difference between the Gross intake ratio(%) of Sub-Saharan Africa (all income levels) and Gross intake ratio(%) of Armenia?
Offer a very short reply. 23.84. In the year 2004, what is the difference between the Gross intake ratio(%) of Sub-Saharan Africa (all income levels) and Gross intake ratio(%) of Ecuador?
Offer a very short reply. -19.02. In the year 2004, what is the difference between the Gross intake ratio(%) in Sub-Saharan Africa (all income levels) and Gross intake ratio(%) in Germany?
Offer a very short reply. 7.68. In the year 2004, what is the difference between the Gross intake ratio(%) of Armenia and Gross intake ratio(%) of Ecuador?
Make the answer very short. -42.86. In the year 2004, what is the difference between the Gross intake ratio(%) in Armenia and Gross intake ratio(%) in Germany?
Your answer should be very brief. -16.16. In the year 2004, what is the difference between the Gross intake ratio(%) in Ecuador and Gross intake ratio(%) in Germany?
Give a very brief answer. 26.7. In the year 2005, what is the difference between the Gross intake ratio(%) in Sub-Saharan Africa (all income levels) and Gross intake ratio(%) in Armenia?
Your answer should be compact. 20.12. In the year 2005, what is the difference between the Gross intake ratio(%) in Sub-Saharan Africa (all income levels) and Gross intake ratio(%) in Ecuador?
Your response must be concise. -12.37. In the year 2005, what is the difference between the Gross intake ratio(%) of Sub-Saharan Africa (all income levels) and Gross intake ratio(%) of Germany?
Your answer should be very brief. 13.31. In the year 2005, what is the difference between the Gross intake ratio(%) in Armenia and Gross intake ratio(%) in Ecuador?
Give a very brief answer. -32.48. In the year 2005, what is the difference between the Gross intake ratio(%) in Armenia and Gross intake ratio(%) in Germany?
Offer a very short reply. -6.81. In the year 2005, what is the difference between the Gross intake ratio(%) in Ecuador and Gross intake ratio(%) in Germany?
Your response must be concise. 25.67. In the year 2006, what is the difference between the Gross intake ratio(%) in Sub-Saharan Africa (all income levels) and Gross intake ratio(%) in Armenia?
Offer a very short reply. 17.28. In the year 2006, what is the difference between the Gross intake ratio(%) of Sub-Saharan Africa (all income levels) and Gross intake ratio(%) of Ecuador?
Give a very brief answer. -17.66. In the year 2006, what is the difference between the Gross intake ratio(%) in Sub-Saharan Africa (all income levels) and Gross intake ratio(%) in Germany?
Offer a very short reply. 11.28. In the year 2006, what is the difference between the Gross intake ratio(%) of Armenia and Gross intake ratio(%) of Ecuador?
Give a very brief answer. -34.93. In the year 2006, what is the difference between the Gross intake ratio(%) of Armenia and Gross intake ratio(%) of Germany?
Make the answer very short. -6. In the year 2006, what is the difference between the Gross intake ratio(%) of Ecuador and Gross intake ratio(%) of Germany?
Your response must be concise. 28.94. What is the ratio of the Gross intake ratio(%) in Sub-Saharan Africa (all income levels) in 1999 to that in 2000?
Your response must be concise. 0.96. What is the ratio of the Gross intake ratio(%) in Ecuador in 1999 to that in 2000?
Give a very brief answer. 0.96. What is the ratio of the Gross intake ratio(%) in Sub-Saharan Africa (all income levels) in 1999 to that in 2002?
Make the answer very short. 0.9. What is the ratio of the Gross intake ratio(%) of Armenia in 1999 to that in 2002?
Offer a very short reply. 0.95. What is the ratio of the Gross intake ratio(%) in Ecuador in 1999 to that in 2002?
Keep it short and to the point. 0.95. What is the ratio of the Gross intake ratio(%) in Germany in 1999 to that in 2002?
Provide a short and direct response. 1.02. What is the ratio of the Gross intake ratio(%) in Sub-Saharan Africa (all income levels) in 1999 to that in 2003?
Keep it short and to the point. 0.88. What is the ratio of the Gross intake ratio(%) in Armenia in 1999 to that in 2003?
Provide a succinct answer. 1.07. What is the ratio of the Gross intake ratio(%) in Ecuador in 1999 to that in 2003?
Ensure brevity in your answer.  0.97. What is the ratio of the Gross intake ratio(%) of Sub-Saharan Africa (all income levels) in 1999 to that in 2004?
Your response must be concise. 0.88. What is the ratio of the Gross intake ratio(%) of Armenia in 1999 to that in 2004?
Provide a succinct answer. 1.1. What is the ratio of the Gross intake ratio(%) in Ecuador in 1999 to that in 2004?
Your response must be concise. 0.99. What is the ratio of the Gross intake ratio(%) in Germany in 1999 to that in 2004?
Your answer should be compact. 0.94. What is the ratio of the Gross intake ratio(%) in Sub-Saharan Africa (all income levels) in 1999 to that in 2005?
Provide a succinct answer. 0.85. What is the ratio of the Gross intake ratio(%) in Armenia in 1999 to that in 2005?
Provide a short and direct response. 1.01. What is the ratio of the Gross intake ratio(%) of Ecuador in 1999 to that in 2005?
Your response must be concise. 1.01. What is the ratio of the Gross intake ratio(%) in Germany in 1999 to that in 2005?
Give a very brief answer. 0.96. What is the ratio of the Gross intake ratio(%) in Sub-Saharan Africa (all income levels) in 1999 to that in 2006?
Make the answer very short. 0.86. What is the ratio of the Gross intake ratio(%) of Armenia in 1999 to that in 2006?
Provide a short and direct response. 0.99. What is the ratio of the Gross intake ratio(%) of Ecuador in 1999 to that in 2006?
Provide a short and direct response. 0.98. What is the ratio of the Gross intake ratio(%) in Germany in 1999 to that in 2006?
Your answer should be compact. 0.95. What is the ratio of the Gross intake ratio(%) of Sub-Saharan Africa (all income levels) in 2000 to that in 2002?
Provide a short and direct response. 0.93. What is the ratio of the Gross intake ratio(%) in Armenia in 2000 to that in 2002?
Your answer should be very brief. 0.95. What is the ratio of the Gross intake ratio(%) in Ecuador in 2000 to that in 2002?
Your answer should be compact. 0.99. What is the ratio of the Gross intake ratio(%) in Germany in 2000 to that in 2002?
Your answer should be compact. 1.02. What is the ratio of the Gross intake ratio(%) of Sub-Saharan Africa (all income levels) in 2000 to that in 2003?
Keep it short and to the point. 0.92. What is the ratio of the Gross intake ratio(%) in Armenia in 2000 to that in 2003?
Provide a short and direct response. 1.06. What is the ratio of the Gross intake ratio(%) in Germany in 2000 to that in 2003?
Keep it short and to the point. 0.98. What is the ratio of the Gross intake ratio(%) of Sub-Saharan Africa (all income levels) in 2000 to that in 2004?
Your response must be concise. 0.91. What is the ratio of the Gross intake ratio(%) in Armenia in 2000 to that in 2004?
Offer a very short reply. 1.09. What is the ratio of the Gross intake ratio(%) of Ecuador in 2000 to that in 2004?
Make the answer very short. 1.03. What is the ratio of the Gross intake ratio(%) of Germany in 2000 to that in 2004?
Your response must be concise. 0.94. What is the ratio of the Gross intake ratio(%) of Sub-Saharan Africa (all income levels) in 2000 to that in 2005?
Provide a succinct answer. 0.88. What is the ratio of the Gross intake ratio(%) of Armenia in 2000 to that in 2005?
Make the answer very short. 1. What is the ratio of the Gross intake ratio(%) of Ecuador in 2000 to that in 2005?
Your answer should be very brief. 1.05. What is the ratio of the Gross intake ratio(%) in Germany in 2000 to that in 2005?
Provide a succinct answer. 0.95. What is the ratio of the Gross intake ratio(%) of Sub-Saharan Africa (all income levels) in 2000 to that in 2006?
Keep it short and to the point. 0.89. What is the ratio of the Gross intake ratio(%) of Ecuador in 2000 to that in 2006?
Offer a very short reply. 1.02. What is the ratio of the Gross intake ratio(%) in Germany in 2000 to that in 2006?
Offer a terse response. 0.95. What is the ratio of the Gross intake ratio(%) of Armenia in 2002 to that in 2003?
Your answer should be compact. 1.12. What is the ratio of the Gross intake ratio(%) of Ecuador in 2002 to that in 2003?
Provide a succinct answer. 1.01. What is the ratio of the Gross intake ratio(%) in Germany in 2002 to that in 2003?
Ensure brevity in your answer.  0.97. What is the ratio of the Gross intake ratio(%) in Sub-Saharan Africa (all income levels) in 2002 to that in 2004?
Provide a short and direct response. 0.98. What is the ratio of the Gross intake ratio(%) in Armenia in 2002 to that in 2004?
Offer a terse response. 1.15. What is the ratio of the Gross intake ratio(%) of Ecuador in 2002 to that in 2004?
Your response must be concise. 1.04. What is the ratio of the Gross intake ratio(%) in Germany in 2002 to that in 2004?
Provide a short and direct response. 0.92. What is the ratio of the Gross intake ratio(%) of Sub-Saharan Africa (all income levels) in 2002 to that in 2005?
Keep it short and to the point. 0.95. What is the ratio of the Gross intake ratio(%) of Armenia in 2002 to that in 2005?
Provide a short and direct response. 1.06. What is the ratio of the Gross intake ratio(%) in Ecuador in 2002 to that in 2005?
Offer a terse response. 1.06. What is the ratio of the Gross intake ratio(%) of Germany in 2002 to that in 2005?
Provide a short and direct response. 0.94. What is the ratio of the Gross intake ratio(%) in Sub-Saharan Africa (all income levels) in 2002 to that in 2006?
Keep it short and to the point. 0.96. What is the ratio of the Gross intake ratio(%) of Armenia in 2002 to that in 2006?
Keep it short and to the point. 1.04. What is the ratio of the Gross intake ratio(%) in Ecuador in 2002 to that in 2006?
Your answer should be very brief. 1.03. What is the ratio of the Gross intake ratio(%) of Germany in 2002 to that in 2006?
Offer a terse response. 0.93. What is the ratio of the Gross intake ratio(%) in Armenia in 2003 to that in 2004?
Your answer should be compact. 1.02. What is the ratio of the Gross intake ratio(%) of Ecuador in 2003 to that in 2004?
Offer a terse response. 1.02. What is the ratio of the Gross intake ratio(%) in Germany in 2003 to that in 2004?
Make the answer very short. 0.95. What is the ratio of the Gross intake ratio(%) in Sub-Saharan Africa (all income levels) in 2003 to that in 2005?
Offer a very short reply. 0.96. What is the ratio of the Gross intake ratio(%) in Armenia in 2003 to that in 2005?
Offer a very short reply. 0.94. What is the ratio of the Gross intake ratio(%) of Ecuador in 2003 to that in 2005?
Your response must be concise. 1.04. What is the ratio of the Gross intake ratio(%) of Germany in 2003 to that in 2005?
Your answer should be very brief. 0.97. What is the ratio of the Gross intake ratio(%) in Sub-Saharan Africa (all income levels) in 2003 to that in 2006?
Your response must be concise. 0.97. What is the ratio of the Gross intake ratio(%) in Armenia in 2003 to that in 2006?
Your answer should be very brief. 0.93. What is the ratio of the Gross intake ratio(%) in Ecuador in 2003 to that in 2006?
Keep it short and to the point. 1.01. What is the ratio of the Gross intake ratio(%) of Germany in 2003 to that in 2006?
Keep it short and to the point. 0.96. What is the ratio of the Gross intake ratio(%) in Sub-Saharan Africa (all income levels) in 2004 to that in 2005?
Offer a very short reply. 0.97. What is the ratio of the Gross intake ratio(%) of Armenia in 2004 to that in 2005?
Offer a very short reply. 0.92. What is the ratio of the Gross intake ratio(%) in Germany in 2004 to that in 2005?
Your response must be concise. 1.02. What is the ratio of the Gross intake ratio(%) in Sub-Saharan Africa (all income levels) in 2004 to that in 2006?
Provide a short and direct response. 0.98. What is the ratio of the Gross intake ratio(%) of Armenia in 2004 to that in 2006?
Offer a terse response. 0.91. What is the ratio of the Gross intake ratio(%) of Ecuador in 2004 to that in 2006?
Provide a succinct answer. 0.99. What is the ratio of the Gross intake ratio(%) of Germany in 2004 to that in 2006?
Ensure brevity in your answer.  1.01. What is the ratio of the Gross intake ratio(%) in Sub-Saharan Africa (all income levels) in 2005 to that in 2006?
Keep it short and to the point. 1.01. What is the ratio of the Gross intake ratio(%) of Armenia in 2005 to that in 2006?
Keep it short and to the point. 0.98. What is the ratio of the Gross intake ratio(%) of Ecuador in 2005 to that in 2006?
Your answer should be compact. 0.97. What is the ratio of the Gross intake ratio(%) in Germany in 2005 to that in 2006?
Offer a very short reply. 0.99. What is the difference between the highest and the second highest Gross intake ratio(%) of Sub-Saharan Africa (all income levels)?
Offer a very short reply. 1.33. What is the difference between the highest and the second highest Gross intake ratio(%) in Armenia?
Your answer should be compact. 4.07. What is the difference between the highest and the second highest Gross intake ratio(%) of Ecuador?
Your answer should be compact. 0.94. What is the difference between the highest and the second highest Gross intake ratio(%) in Germany?
Make the answer very short. 0.98. What is the difference between the highest and the lowest Gross intake ratio(%) in Sub-Saharan Africa (all income levels)?
Provide a succinct answer. 17.89. What is the difference between the highest and the lowest Gross intake ratio(%) of Armenia?
Make the answer very short. 13.26. What is the difference between the highest and the lowest Gross intake ratio(%) in Ecuador?
Make the answer very short. 7.34. What is the difference between the highest and the lowest Gross intake ratio(%) of Germany?
Make the answer very short. 8.3. 